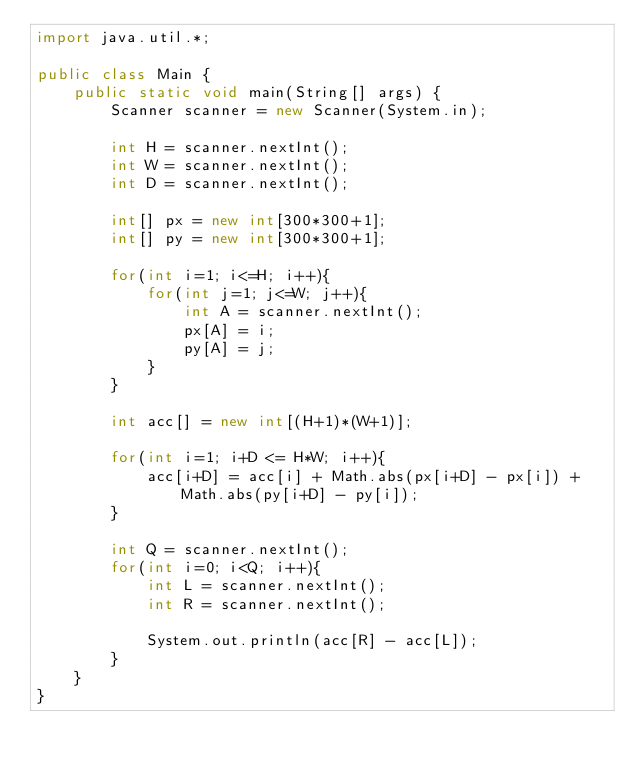<code> <loc_0><loc_0><loc_500><loc_500><_Java_>import java.util.*;

public class Main {
    public static void main(String[] args) {
        Scanner scanner = new Scanner(System.in);

        int H = scanner.nextInt();
        int W = scanner.nextInt();
        int D = scanner.nextInt();

        int[] px = new int[300*300+1];
        int[] py = new int[300*300+1];

        for(int i=1; i<=H; i++){
            for(int j=1; j<=W; j++){
                int A = scanner.nextInt();
                px[A] = i;
                py[A] = j;
            }
        }

        int acc[] = new int[(H+1)*(W+1)];

        for(int i=1; i+D <= H*W; i++){
            acc[i+D] = acc[i] + Math.abs(px[i+D] - px[i]) + Math.abs(py[i+D] - py[i]);
        }

        int Q = scanner.nextInt();
        for(int i=0; i<Q; i++){
            int L = scanner.nextInt();
            int R = scanner.nextInt();

            System.out.println(acc[R] - acc[L]);
        }
    }
}
</code> 